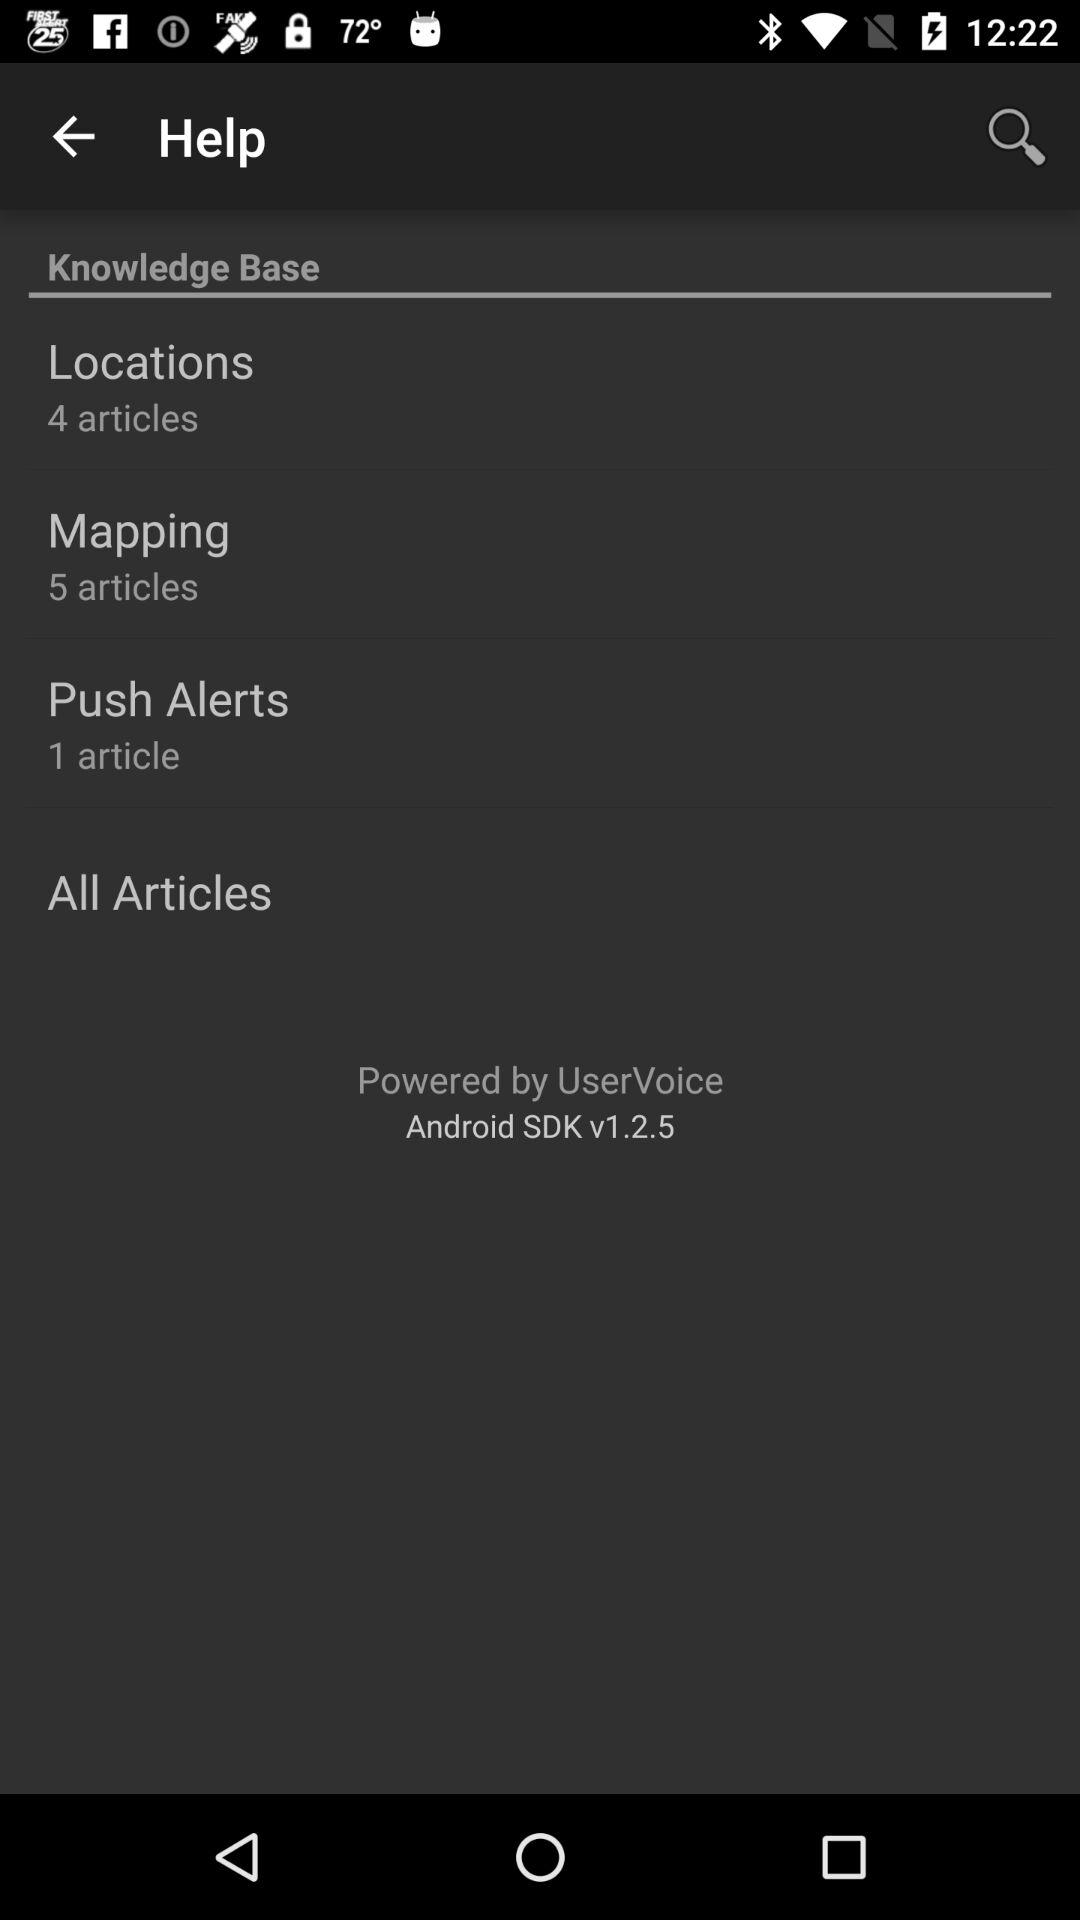How many articles are there in "Mapping"? There are 5 articles in "Mapping". 